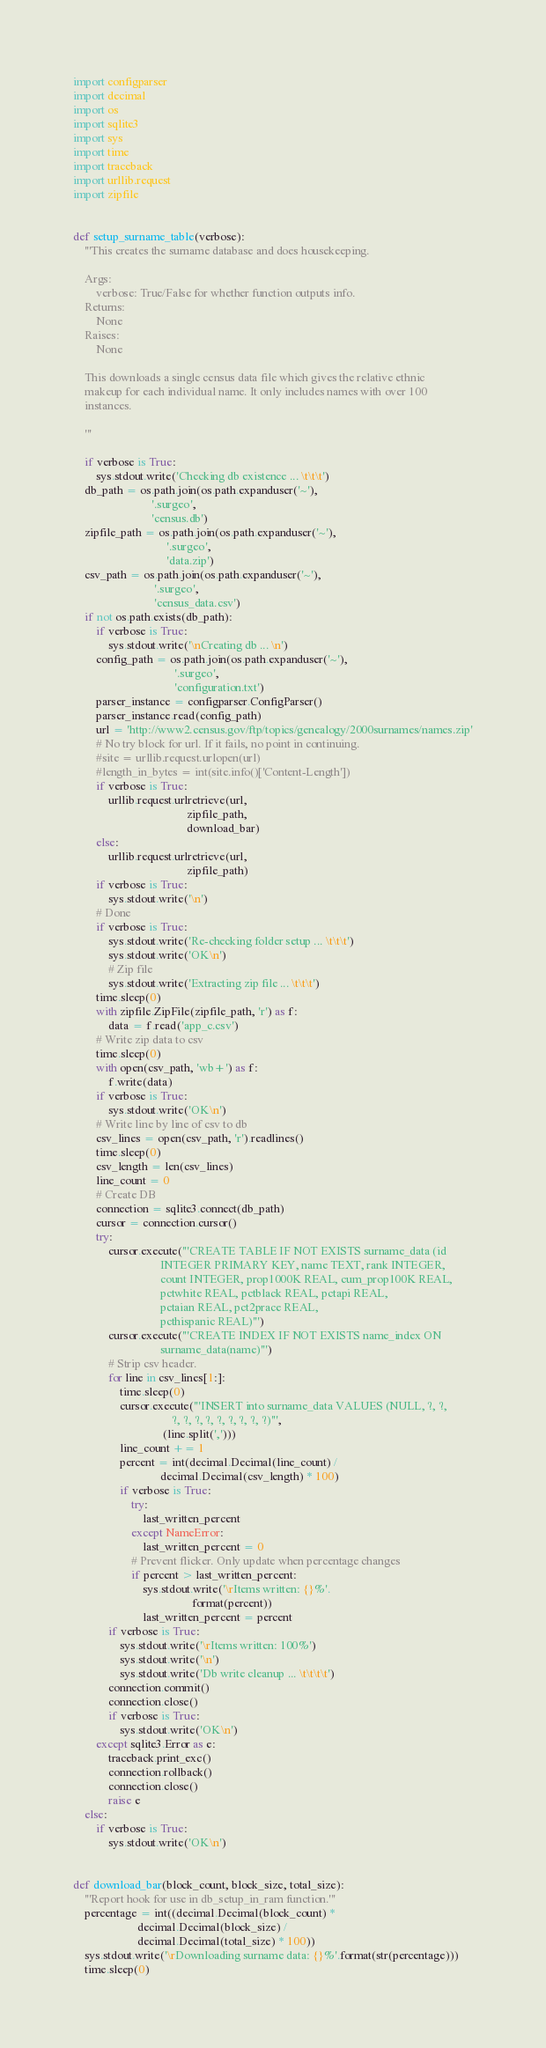Convert code to text. <code><loc_0><loc_0><loc_500><loc_500><_Python_>
import configparser
import decimal
import os
import sqlite3
import sys
import time
import traceback
import urllib.request
import zipfile


def setup_surname_table(verbose):
    '''This creates the surname database and does housekeeping.

    Args:
        verbose: True/False for whether function outputs info.
    Returns:
        None
    Raises:
        None

    This downloads a single census data file which gives the relative ethnic
    makeup for each individual name. It only includes names with over 100
    instances.

    '''

    if verbose is True:
        sys.stdout.write('Checking db existence ... \t\t\t')
    db_path = os.path.join(os.path.expanduser('~'),
                           '.surgeo',
                           'census.db')
    zipfile_path = os.path.join(os.path.expanduser('~'),
                                '.surgeo',
                                'data.zip')
    csv_path = os.path.join(os.path.expanduser('~'),
                            '.surgeo',
                            'census_data.csv')
    if not os.path.exists(db_path):
        if verbose is True:
            sys.stdout.write('\nCreating db ... \n')
        config_path = os.path.join(os.path.expanduser('~'),
                                   '.surgeo',
                                   'configuration.txt')
        parser_instance = configparser.ConfigParser()
        parser_instance.read(config_path)
        url = 'http://www2.census.gov/ftp/topics/genealogy/2000surnames/names.zip'
        # No try block for url. If it fails, no point in continuing.
        #site = urllib.request.urlopen(url)
        #length_in_bytes = int(site.info()['Content-Length'])
        if verbose is True:
            urllib.request.urlretrieve(url,
                                       zipfile_path,
                                       download_bar)
        else:
            urllib.request.urlretrieve(url,
                                       zipfile_path)
        if verbose is True:
            sys.stdout.write('\n')
        # Done
        if verbose is True:
            sys.stdout.write('Re-checking folder setup ... \t\t\t')
            sys.stdout.write('OK\n')
            # Zip file
            sys.stdout.write('Extracting zip file ... \t\t\t')
        time.sleep(0)
        with zipfile.ZipFile(zipfile_path, 'r') as f:
            data = f.read('app_c.csv')
        # Write zip data to csv
        time.sleep(0)
        with open(csv_path, 'wb+') as f:
            f.write(data)
        if verbose is True:
            sys.stdout.write('OK\n')
        # Write line by line of csv to db
        csv_lines = open(csv_path, 'r').readlines()
        time.sleep(0)
        csv_length = len(csv_lines)
        line_count = 0
        # Create DB
        connection = sqlite3.connect(db_path)
        cursor = connection.cursor()
        try:
            cursor.execute('''CREATE TABLE IF NOT EXISTS surname_data (id
                              INTEGER PRIMARY KEY, name TEXT, rank INTEGER,
                              count INTEGER, prop1000K REAL, cum_prop100K REAL,
                              pctwhite REAL, pctblack REAL, pctapi REAL,
                              pctaian REAL, pct2prace REAL,
                              pcthispanic REAL)''')
            cursor.execute('''CREATE INDEX IF NOT EXISTS name_index ON
                              surname_data(name)''')
            # Strip csv header.
            for line in csv_lines[1:]:
                time.sleep(0)
                cursor.execute('''INSERT into surname_data VALUES (NULL, ?, ?,
                                  ?, ?, ?, ?, ?, ?, ?, ?, ?)''',
                               (line.split(',')))
                line_count += 1
                percent = int(decimal.Decimal(line_count) /
                              decimal.Decimal(csv_length) * 100)
                if verbose is True:
                    try:
                        last_written_percent
                    except NameError:
                        last_written_percent = 0
                    # Prevent flicker. Only update when percentage changes
                    if percent > last_written_percent:
                        sys.stdout.write('\rItems written: {}%'.
                                         format(percent))
                        last_written_percent = percent
            if verbose is True:
                sys.stdout.write('\rItems written: 100%')
                sys.stdout.write('\n')
                sys.stdout.write('Db write cleanup ... \t\t\t\t')
            connection.commit()
            connection.close()
            if verbose is True:
                sys.stdout.write('OK\n')
        except sqlite3.Error as e:
            traceback.print_exc()
            connection.rollback()
            connection.close()
            raise e
    else:
        if verbose is True:
            sys.stdout.write('OK\n')


def download_bar(block_count, block_size, total_size):
    '''Report hook for use in db_setup_in_ram function.'''
    percentage = int((decimal.Decimal(block_count) *
                      decimal.Decimal(block_size) /
                      decimal.Decimal(total_size) * 100))
    sys.stdout.write('\rDownloading surname data: {}%'.format(str(percentage)))
    time.sleep(0)
</code> 